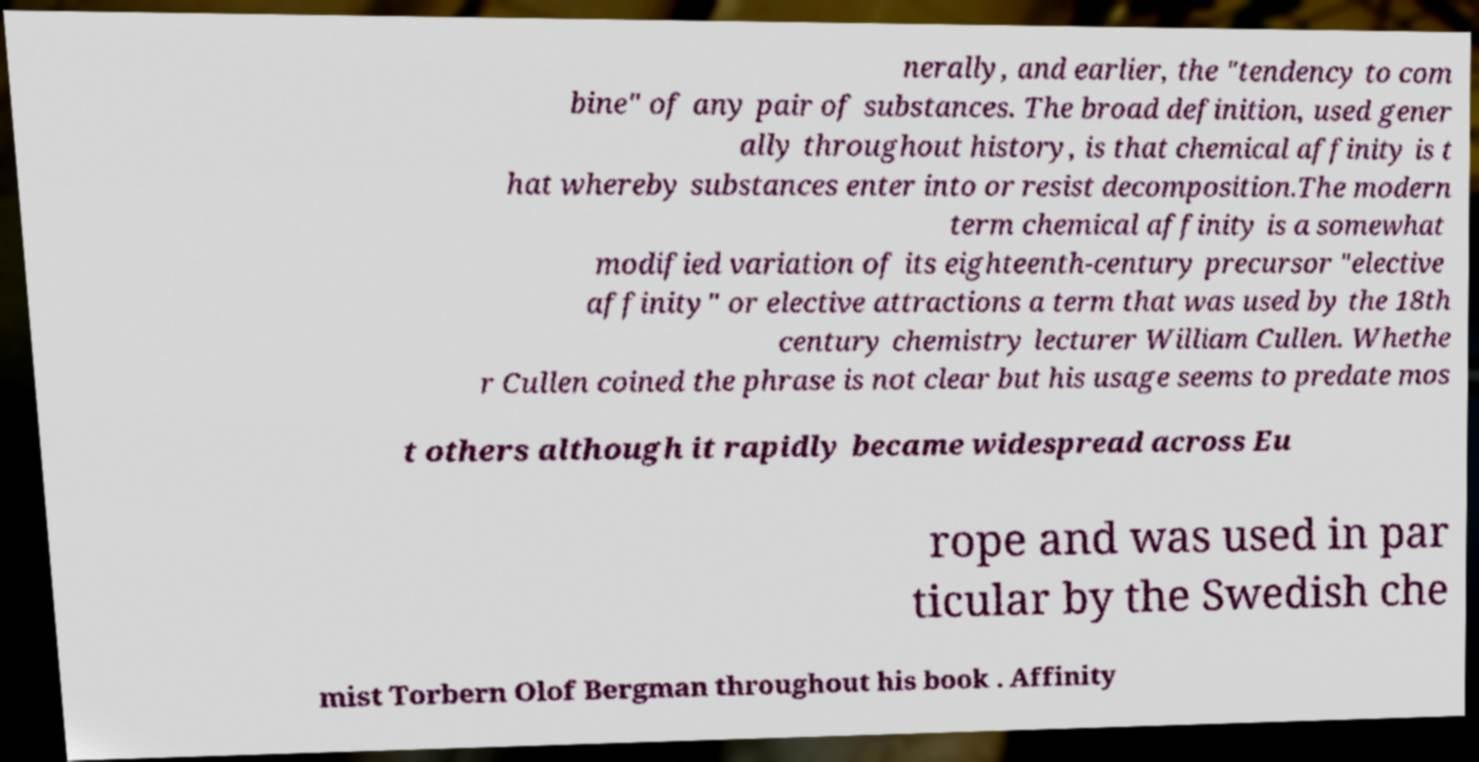Could you extract and type out the text from this image? nerally, and earlier, the ″tendency to com bine″ of any pair of substances. The broad definition, used gener ally throughout history, is that chemical affinity is t hat whereby substances enter into or resist decomposition.The modern term chemical affinity is a somewhat modified variation of its eighteenth-century precursor "elective affinity" or elective attractions a term that was used by the 18th century chemistry lecturer William Cullen. Whethe r Cullen coined the phrase is not clear but his usage seems to predate mos t others although it rapidly became widespread across Eu rope and was used in par ticular by the Swedish che mist Torbern Olof Bergman throughout his book . Affinity 